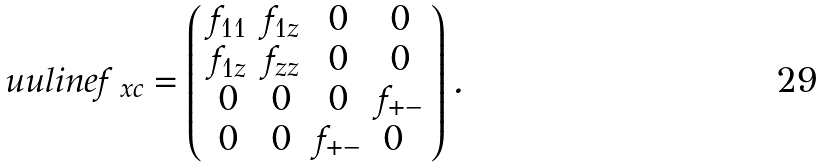Convert formula to latex. <formula><loc_0><loc_0><loc_500><loc_500>\ u u l i n e { f _ { \ x c } } = \left ( \begin{array} { c c c c } f _ { 1 1 } & f _ { 1 z } & 0 & 0 \\ f _ { 1 z } & f _ { z z } & 0 & 0 \\ 0 & 0 & 0 & f _ { + - } \\ 0 & 0 & f _ { + - } & 0 \ \end{array} \right ) .</formula> 